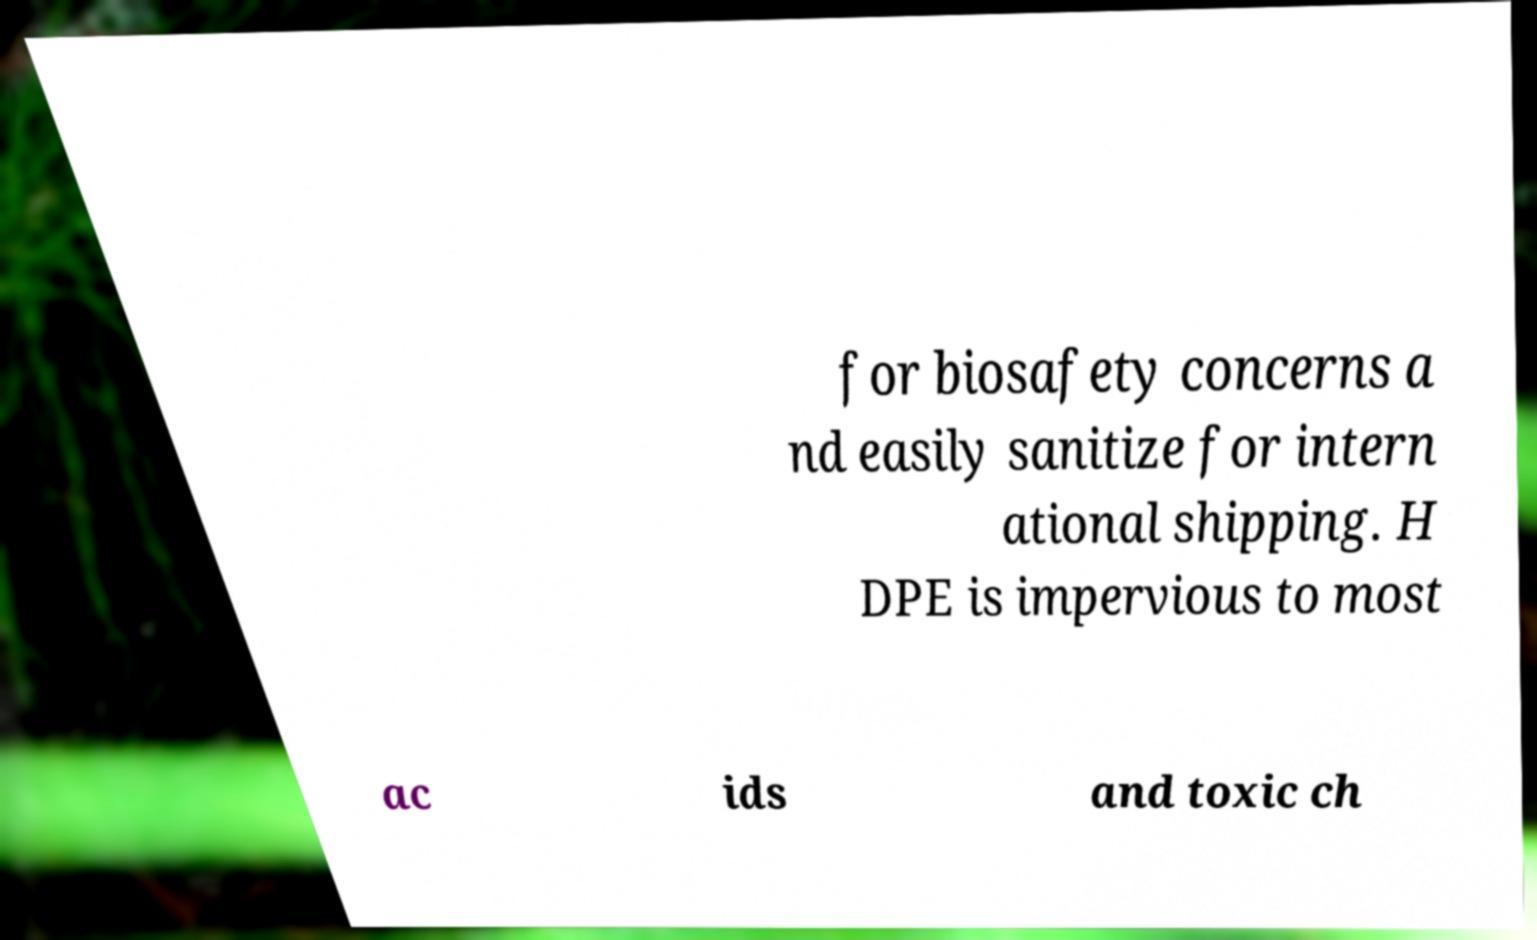For documentation purposes, I need the text within this image transcribed. Could you provide that? for biosafety concerns a nd easily sanitize for intern ational shipping. H DPE is impervious to most ac ids and toxic ch 